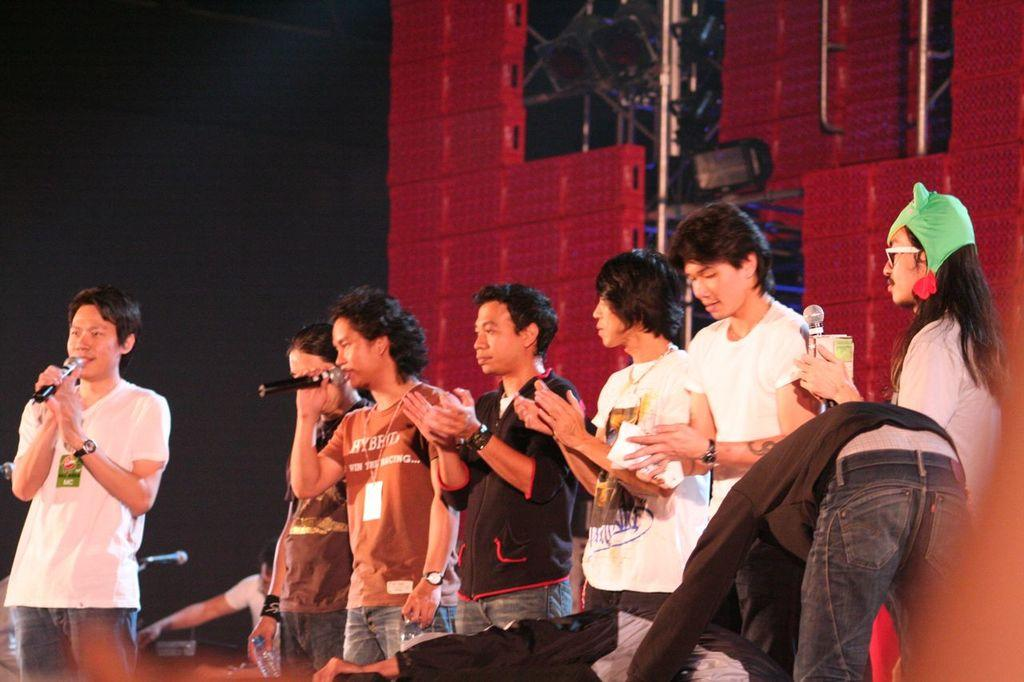What are the people in the image doing? A: The people in the image are standing, and some of them are holding microphones. What can be seen in the background of the image? There are red color boxes in the background of the image. Can you describe the lighting in the image? There is a light visible in the image. Are there any firemen working in the garden in the image? There is no garden or firemen present in the image. 